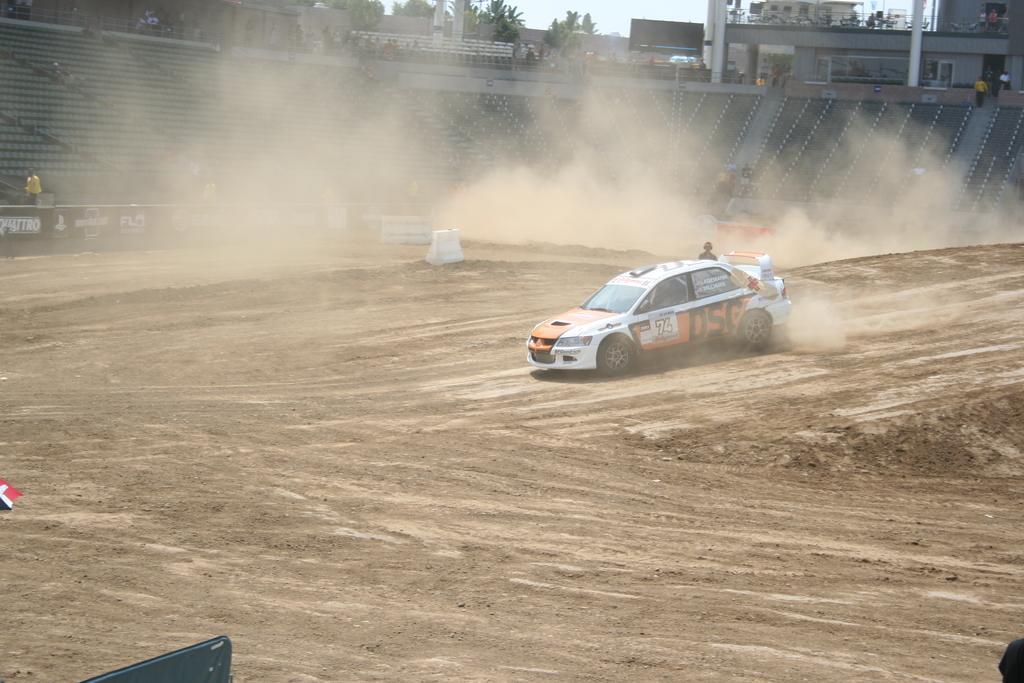Could you give a brief overview of what you see in this image? In the middle of the image we can see a vehicle. Behind the vehicle a person is standing and there is dust. Behind them there is fencing. Behind the fencing there is a stadium. In the stadium few people are standing and watching. At the top of the image there are some trees and poles and buildings. 